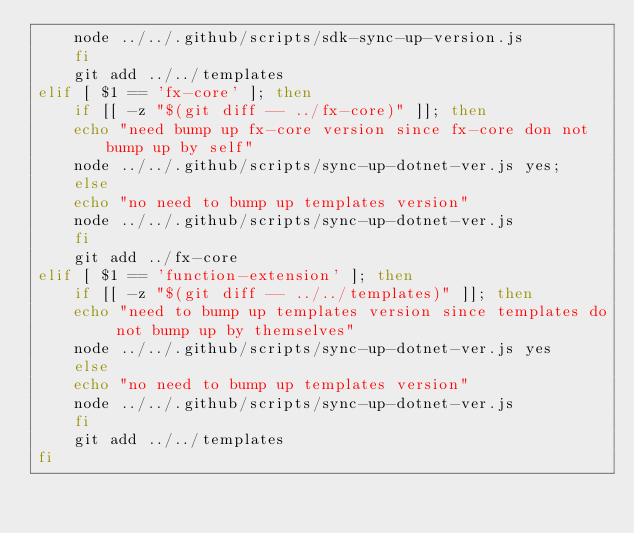Convert code to text. <code><loc_0><loc_0><loc_500><loc_500><_Bash_>    node ../../.github/scripts/sdk-sync-up-version.js 
    fi
    git add ../../templates
elif [ $1 == 'fx-core' ]; then
    if [[ -z "$(git diff -- ../fx-core)" ]]; then
    echo "need bump up fx-core version since fx-core don not bump up by self"
    node ../../.github/scripts/sync-up-dotnet-ver.js yes;
    else 
    echo "no need to bump up templates version"
    node ../../.github/scripts/sync-up-dotnet-ver.js
    fi
    git add ../fx-core
elif [ $1 == 'function-extension' ]; then   
    if [[ -z "$(git diff -- ../../templates)" ]]; then
    echo "need to bump up templates version since templates do not bump up by themselves"
    node ../../.github/scripts/sync-up-dotnet-ver.js yes
    else 
    echo "no need to bump up templates version"
    node ../../.github/scripts/sync-up-dotnet-ver.js
    fi
    git add ../../templates
fi</code> 